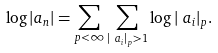Convert formula to latex. <formula><loc_0><loc_0><loc_500><loc_500>\log | a _ { n } | & = \sum _ { p < \infty } \sum _ { | \ a _ { i } | _ { p } > 1 } \log | \ a _ { i } | _ { p } .</formula> 